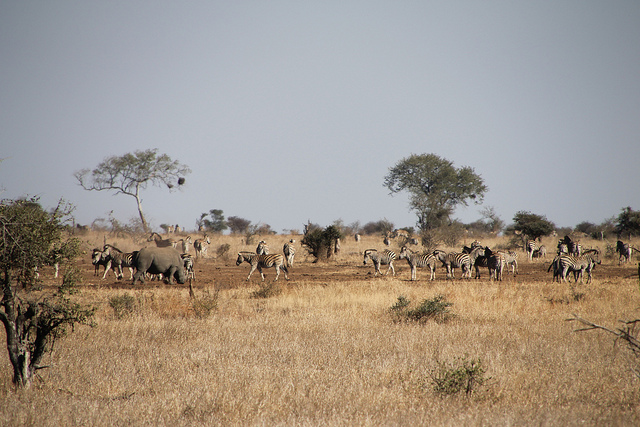Can you estimate the time of day this photo was taken? Based on the length and direction of the shadow cast by the trees, and the golden hue of the sunlight, it seems likely that this photo was taken either in the early morning or late afternoon. 